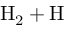Convert formula to latex. <formula><loc_0><loc_0><loc_500><loc_500>H _ { 2 } + H</formula> 